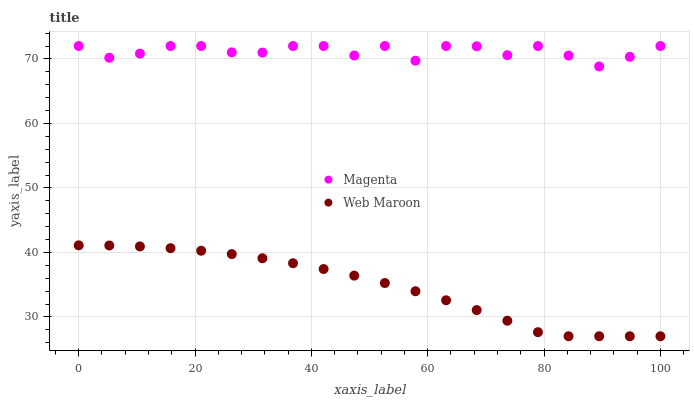Does Web Maroon have the minimum area under the curve?
Answer yes or no. Yes. Does Magenta have the maximum area under the curve?
Answer yes or no. Yes. Does Web Maroon have the maximum area under the curve?
Answer yes or no. No. Is Web Maroon the smoothest?
Answer yes or no. Yes. Is Magenta the roughest?
Answer yes or no. Yes. Is Web Maroon the roughest?
Answer yes or no. No. Does Web Maroon have the lowest value?
Answer yes or no. Yes. Does Magenta have the highest value?
Answer yes or no. Yes. Does Web Maroon have the highest value?
Answer yes or no. No. Is Web Maroon less than Magenta?
Answer yes or no. Yes. Is Magenta greater than Web Maroon?
Answer yes or no. Yes. Does Web Maroon intersect Magenta?
Answer yes or no. No. 